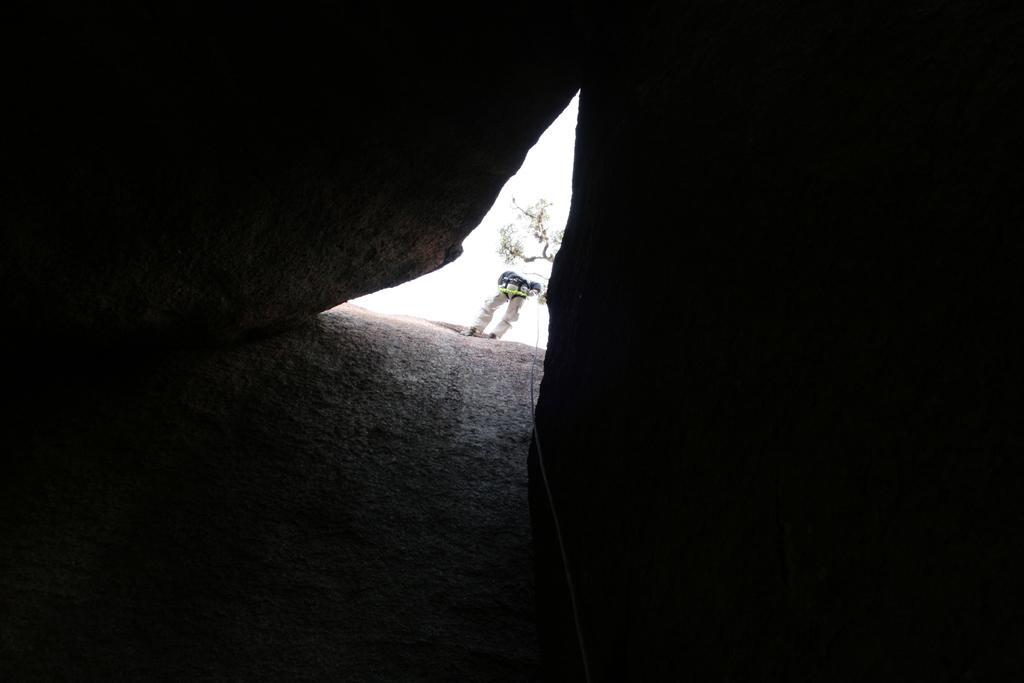Can you describe this image briefly? In the middle of the picture, we see a man is standing and he is holding a rope in his hands. On either side of the picture, we see the rocks. At the bottom, we see the rock. In the background, we see a tree and the sky. 